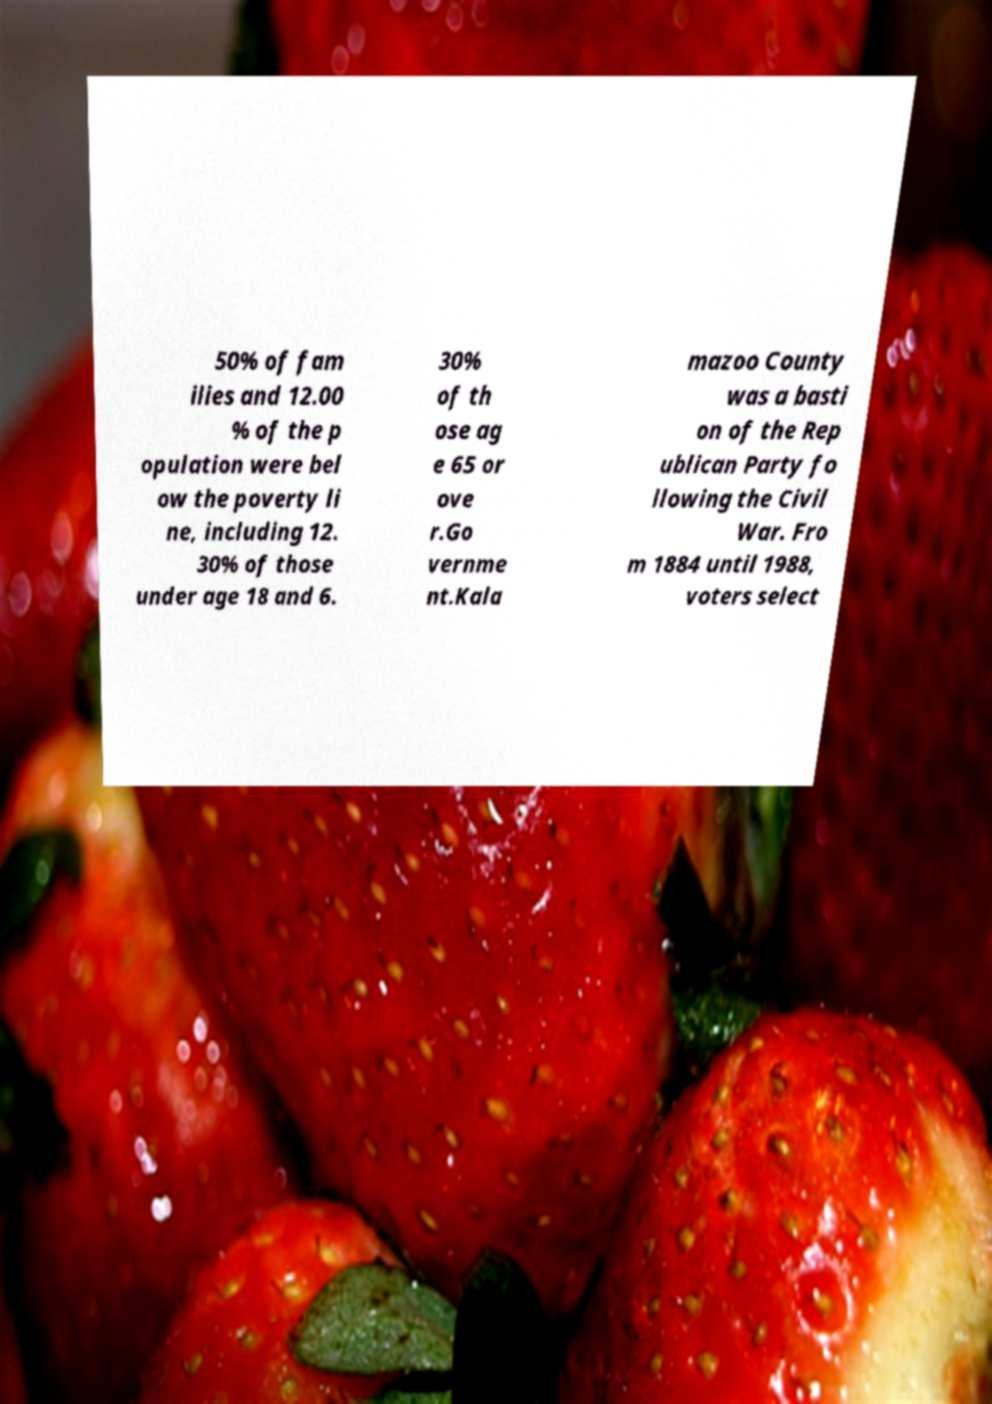Please identify and transcribe the text found in this image. 50% of fam ilies and 12.00 % of the p opulation were bel ow the poverty li ne, including 12. 30% of those under age 18 and 6. 30% of th ose ag e 65 or ove r.Go vernme nt.Kala mazoo County was a basti on of the Rep ublican Party fo llowing the Civil War. Fro m 1884 until 1988, voters select 